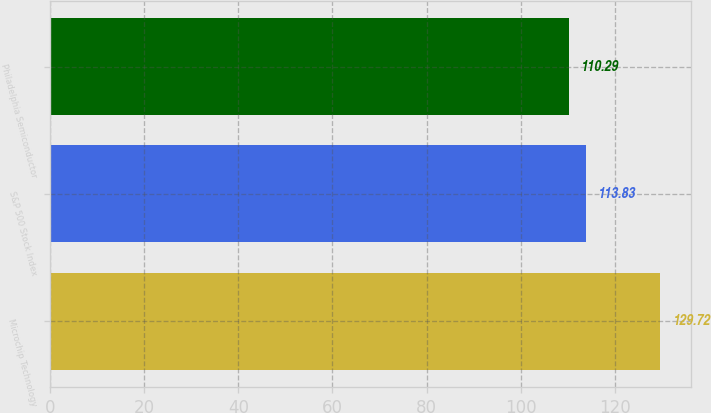Convert chart. <chart><loc_0><loc_0><loc_500><loc_500><bar_chart><fcel>Microchip Technology<fcel>S&P 500 Stock Index<fcel>Philadelphia Semiconductor<nl><fcel>129.72<fcel>113.83<fcel>110.29<nl></chart> 